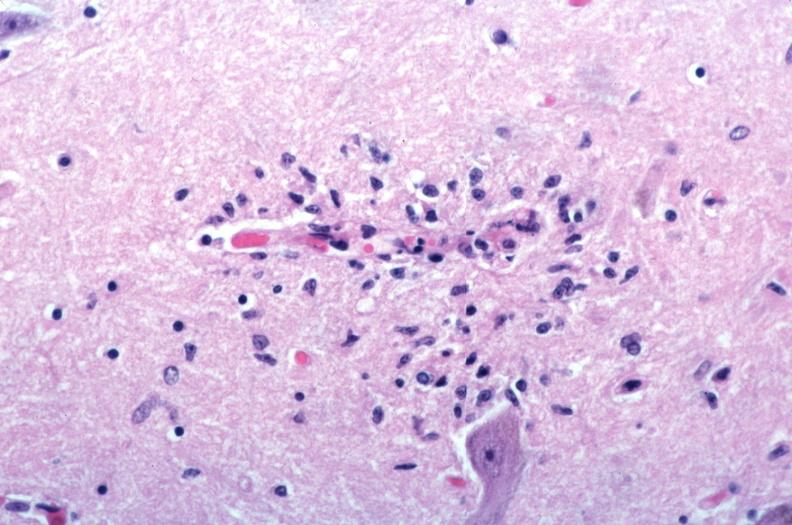what is vasculitis due to rocky mountain spotted?
Answer the question using a single word or phrase. Fever 